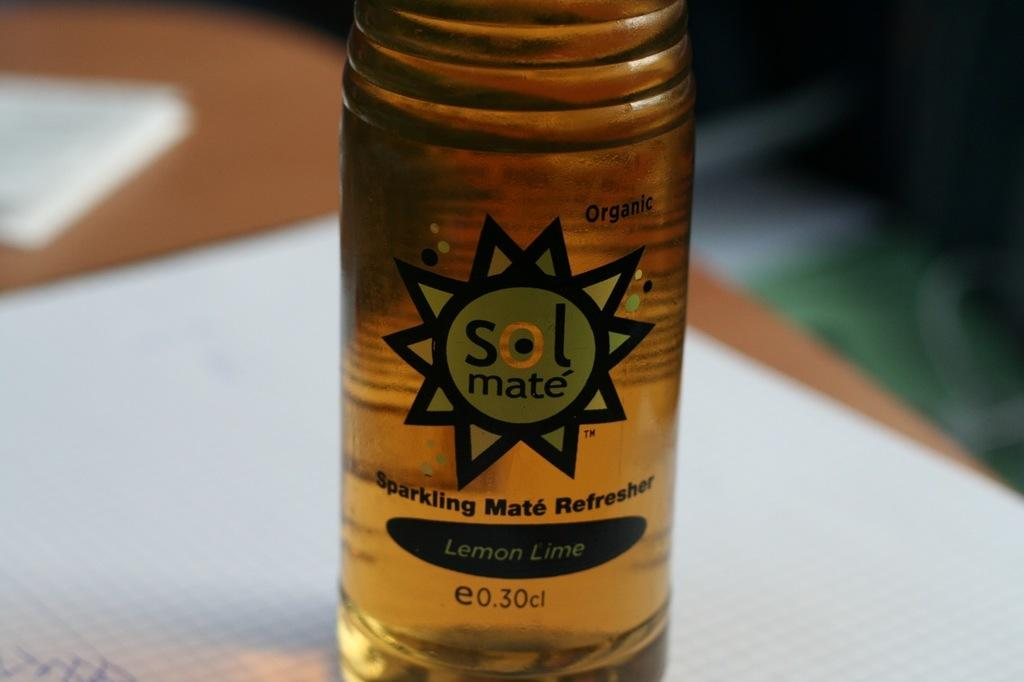<image>
Create a compact narrative representing the image presented. a bottle of sol mate sparkling mate refresher 